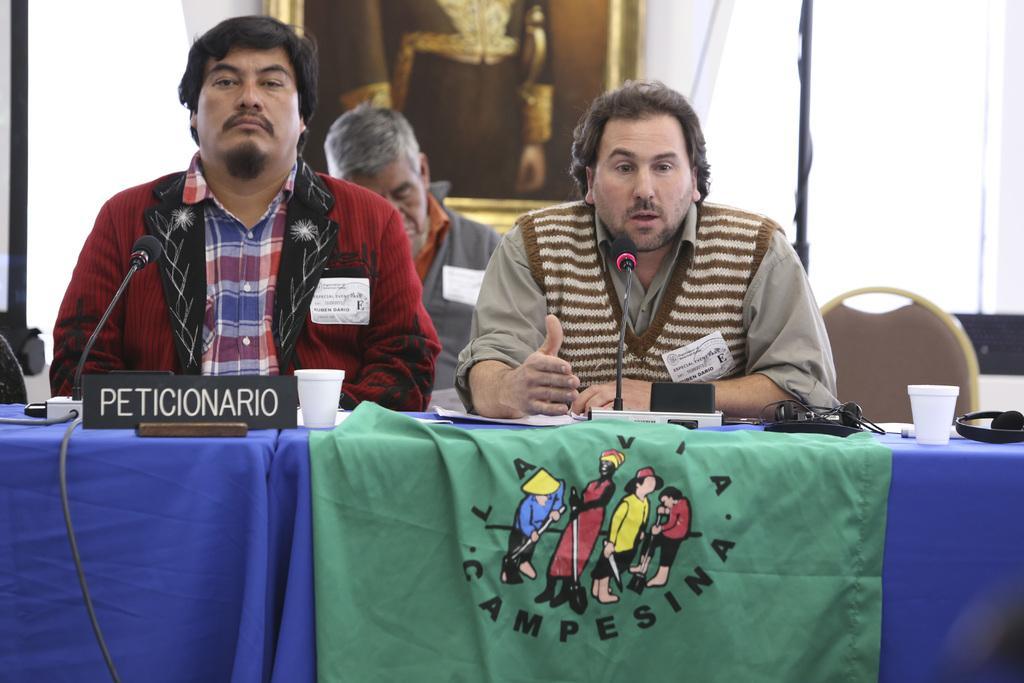Describe this image in one or two sentences. This picture is taken inside the room. In this image, we can see three people are sitting on the chair. On the table, we can see a blue colored cloth, board with some text written on it, microphone, glass, electrical wires. On the right side, we can see a black color pole and white color. In the background, we can see a photo frame which is attached to a wall. 